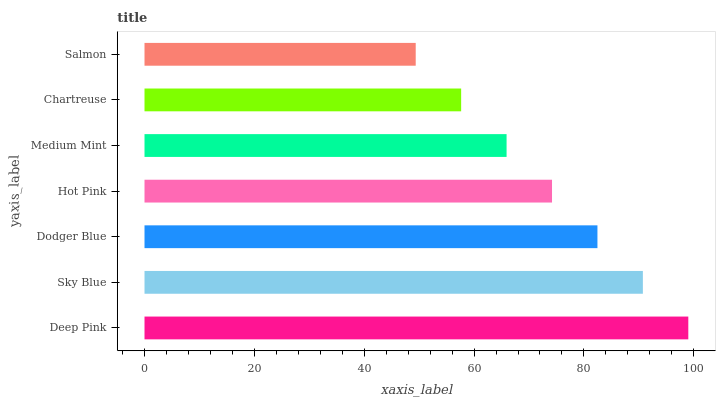Is Salmon the minimum?
Answer yes or no. Yes. Is Deep Pink the maximum?
Answer yes or no. Yes. Is Sky Blue the minimum?
Answer yes or no. No. Is Sky Blue the maximum?
Answer yes or no. No. Is Deep Pink greater than Sky Blue?
Answer yes or no. Yes. Is Sky Blue less than Deep Pink?
Answer yes or no. Yes. Is Sky Blue greater than Deep Pink?
Answer yes or no. No. Is Deep Pink less than Sky Blue?
Answer yes or no. No. Is Hot Pink the high median?
Answer yes or no. Yes. Is Hot Pink the low median?
Answer yes or no. Yes. Is Dodger Blue the high median?
Answer yes or no. No. Is Salmon the low median?
Answer yes or no. No. 